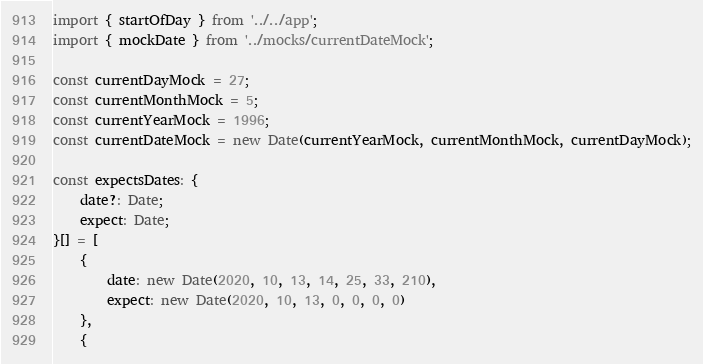Convert code to text. <code><loc_0><loc_0><loc_500><loc_500><_TypeScript_>import { startOfDay } from '../../app';
import { mockDate } from '../mocks/currentDateMock';

const currentDayMock = 27;
const currentMonthMock = 5;
const currentYearMock = 1996;
const currentDateMock = new Date(currentYearMock, currentMonthMock, currentDayMock);

const expectsDates: {
    date?: Date;
    expect: Date;
}[] = [
    {
        date: new Date(2020, 10, 13, 14, 25, 33, 210),
        expect: new Date(2020, 10, 13, 0, 0, 0, 0)
    },
    {</code> 